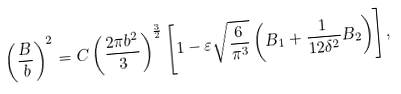Convert formula to latex. <formula><loc_0><loc_0><loc_500><loc_500>\left ( \frac { B } { b } \right ) ^ { 2 } = C \left ( \frac { 2 \pi b ^ { 2 } } { 3 } \right ) ^ { \frac { 3 } { 2 } } \left [ 1 - \varepsilon \sqrt { \frac { 6 } { \pi ^ { 3 } } } \left ( B _ { 1 } + \frac { 1 } { 1 2 \delta ^ { 2 } } B _ { 2 } \right ) \right ] ,</formula> 